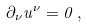Convert formula to latex. <formula><loc_0><loc_0><loc_500><loc_500>\partial _ { \nu } u ^ { \nu } = 0 \, ,</formula> 